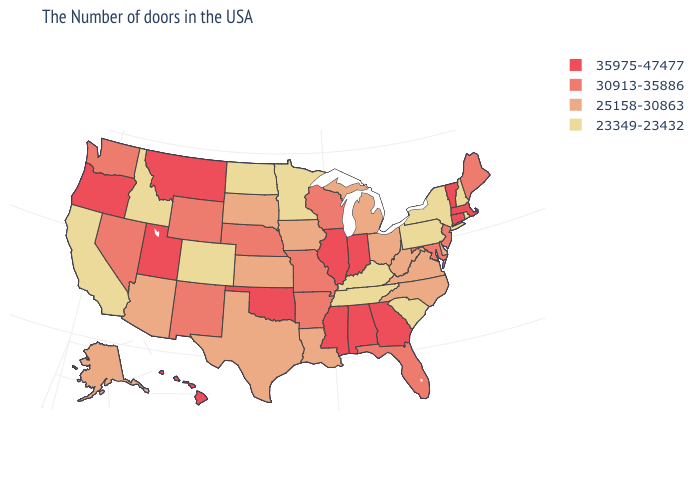What is the highest value in states that border Maryland?
Quick response, please. 25158-30863. Among the states that border Vermont , which have the lowest value?
Short answer required. New Hampshire, New York. What is the lowest value in states that border Louisiana?
Keep it brief. 25158-30863. Name the states that have a value in the range 25158-30863?
Short answer required. Delaware, Virginia, North Carolina, West Virginia, Ohio, Michigan, Louisiana, Iowa, Kansas, Texas, South Dakota, Arizona, Alaska. Does Illinois have the highest value in the USA?
Write a very short answer. Yes. Does Texas have the same value as Wyoming?
Answer briefly. No. Name the states that have a value in the range 25158-30863?
Short answer required. Delaware, Virginia, North Carolina, West Virginia, Ohio, Michigan, Louisiana, Iowa, Kansas, Texas, South Dakota, Arizona, Alaska. What is the value of Georgia?
Answer briefly. 35975-47477. Name the states that have a value in the range 25158-30863?
Answer briefly. Delaware, Virginia, North Carolina, West Virginia, Ohio, Michigan, Louisiana, Iowa, Kansas, Texas, South Dakota, Arizona, Alaska. Name the states that have a value in the range 30913-35886?
Quick response, please. Maine, New Jersey, Maryland, Florida, Wisconsin, Missouri, Arkansas, Nebraska, Wyoming, New Mexico, Nevada, Washington. What is the lowest value in the West?
Quick response, please. 23349-23432. What is the highest value in the Northeast ?
Keep it brief. 35975-47477. What is the value of Washington?
Write a very short answer. 30913-35886. Does Kentucky have the lowest value in the USA?
Short answer required. Yes. Name the states that have a value in the range 23349-23432?
Short answer required. Rhode Island, New Hampshire, New York, Pennsylvania, South Carolina, Kentucky, Tennessee, Minnesota, North Dakota, Colorado, Idaho, California. 